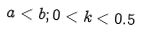<formula> <loc_0><loc_0><loc_500><loc_500>a < b ; 0 < k < 0 . 5</formula> 